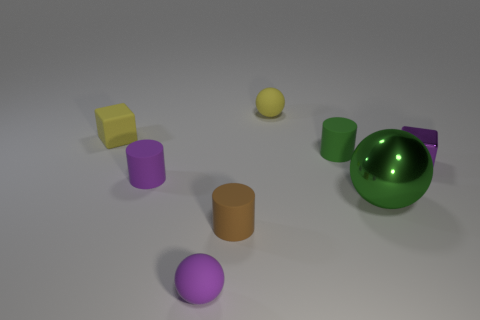There is a green object that is behind the cube in front of the tiny yellow rubber cube that is to the left of the tiny green matte thing; what is its shape?
Keep it short and to the point. Cylinder. Do the block that is in front of the small matte block and the small ball that is in front of the tiny yellow sphere have the same color?
Offer a terse response. Yes. Are there any other things that are the same size as the shiny ball?
Offer a terse response. No. Are there any purple things on the left side of the tiny brown rubber thing?
Offer a very short reply. Yes. How many large gray metal things are the same shape as the purple metal thing?
Offer a terse response. 0. The matte sphere behind the small matte sphere that is in front of the purple object that is right of the green metallic ball is what color?
Your answer should be very brief. Yellow. Do the cylinder behind the tiny purple block and the block that is in front of the tiny yellow rubber cube have the same material?
Ensure brevity in your answer.  No. How many objects are tiny matte things in front of the tiny green rubber cylinder or yellow things?
Provide a succinct answer. 5. What number of objects are large yellow shiny objects or small cylinders in front of the big green metallic object?
Keep it short and to the point. 1. What number of brown cylinders have the same size as the green cylinder?
Make the answer very short. 1. 